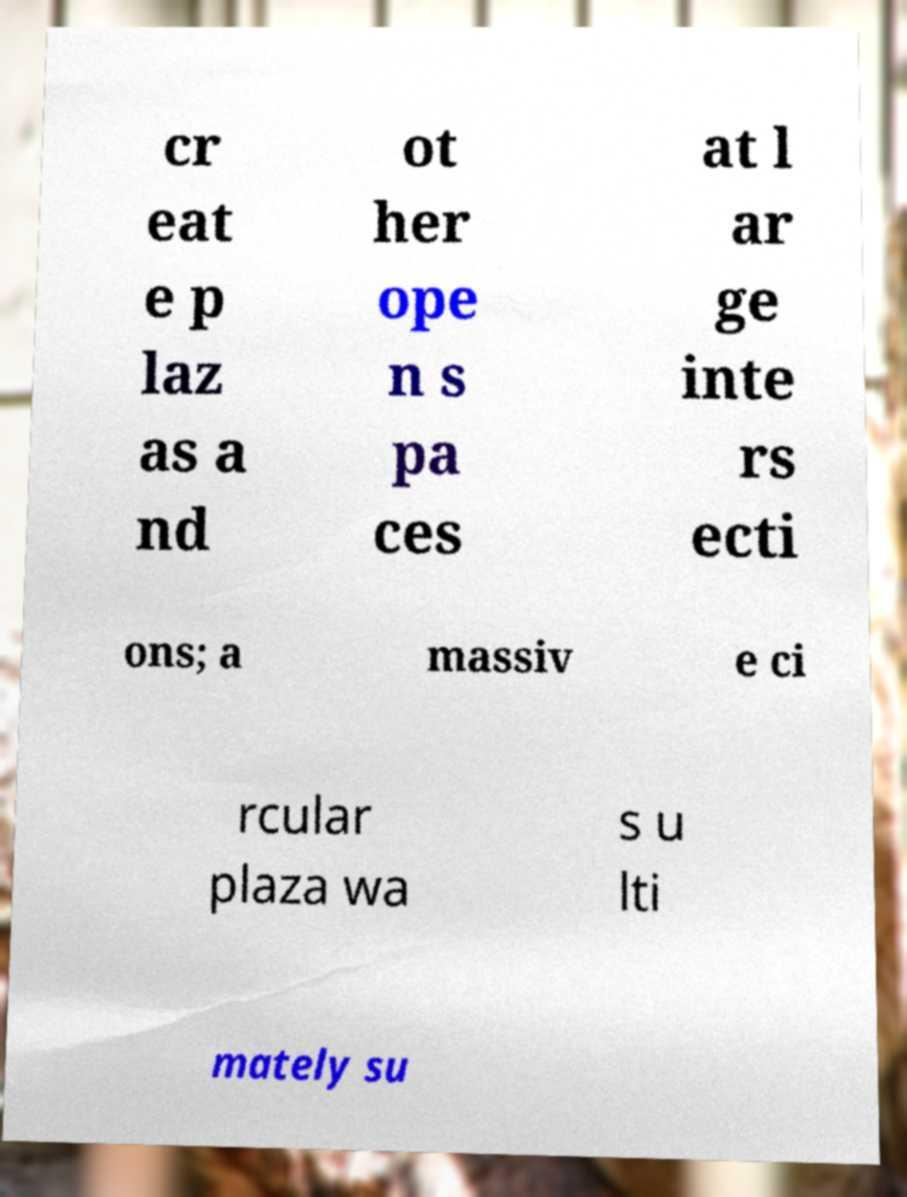I need the written content from this picture converted into text. Can you do that? cr eat e p laz as a nd ot her ope n s pa ces at l ar ge inte rs ecti ons; a massiv e ci rcular plaza wa s u lti mately su 